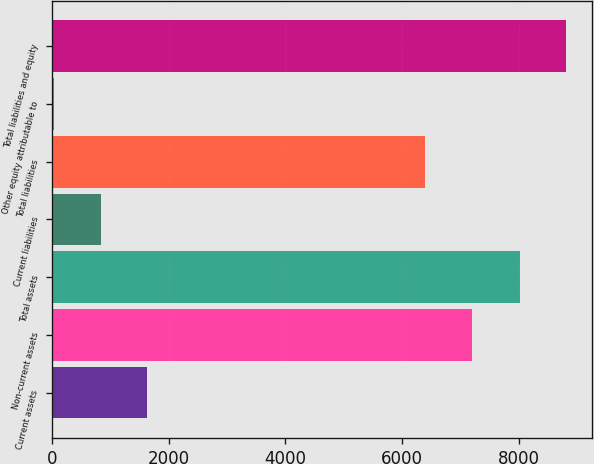<chart> <loc_0><loc_0><loc_500><loc_500><bar_chart><fcel>Current assets<fcel>Non-current assets<fcel>Total assets<fcel>Current liabilities<fcel>Total liabilities<fcel>Other equity attributable to<fcel>Total liabilities and equity<nl><fcel>1635.02<fcel>7205.5<fcel>8022.3<fcel>836.61<fcel>6397.1<fcel>38.2<fcel>8820.71<nl></chart> 